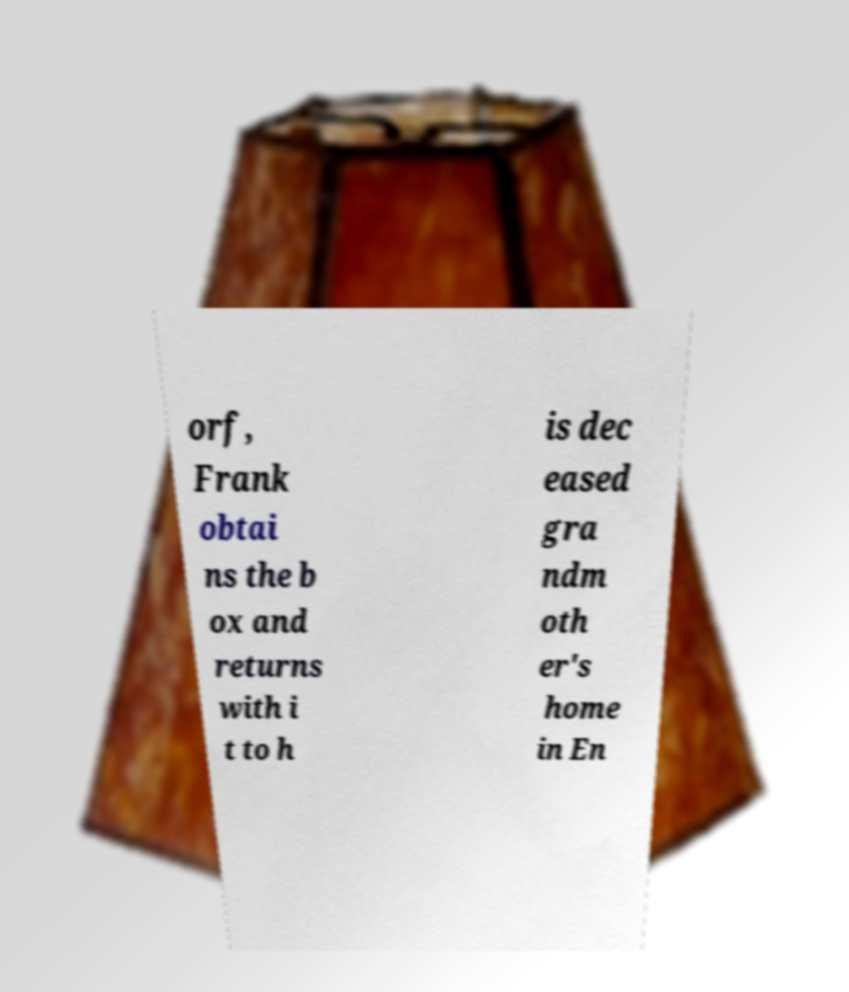Can you read and provide the text displayed in the image?This photo seems to have some interesting text. Can you extract and type it out for me? orf, Frank obtai ns the b ox and returns with i t to h is dec eased gra ndm oth er's home in En 